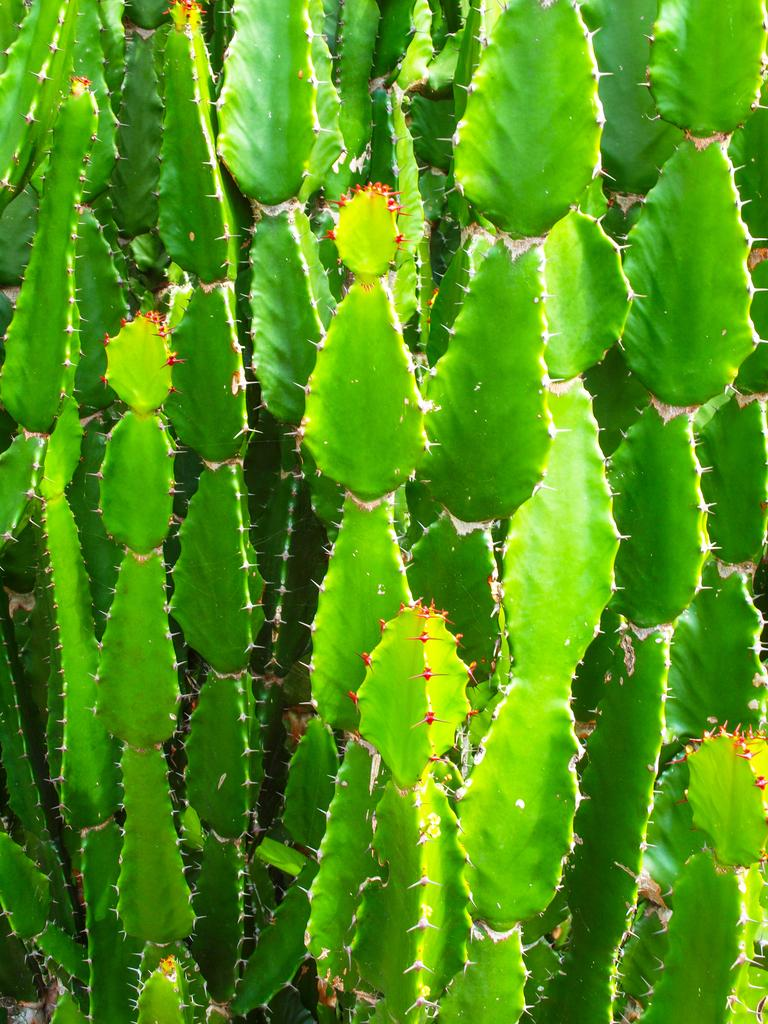What type of plants are in the image? There are cactus plants in the image. Can you describe the appearance of the cactus plants? The cactus plants have spiky features and may have different shapes and sizes. Are there any other objects or elements in the image besides the cactus plants? The provided facts do not mention any other objects or elements in the image. What type of food is being prepared on the cactus plants in the image? There is no food preparation or any other objects or elements in the image besides the cactus plants, so it is not possible to answer that question. 